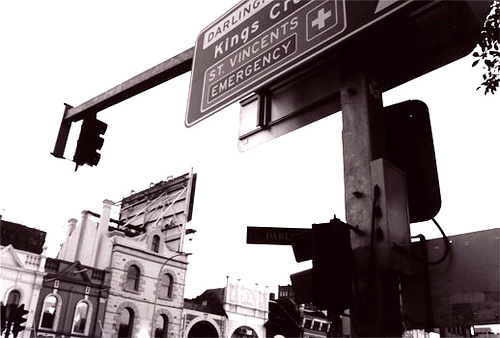Read and extract the text from this image. DARLING Kings CR Kings EMERGENCY 